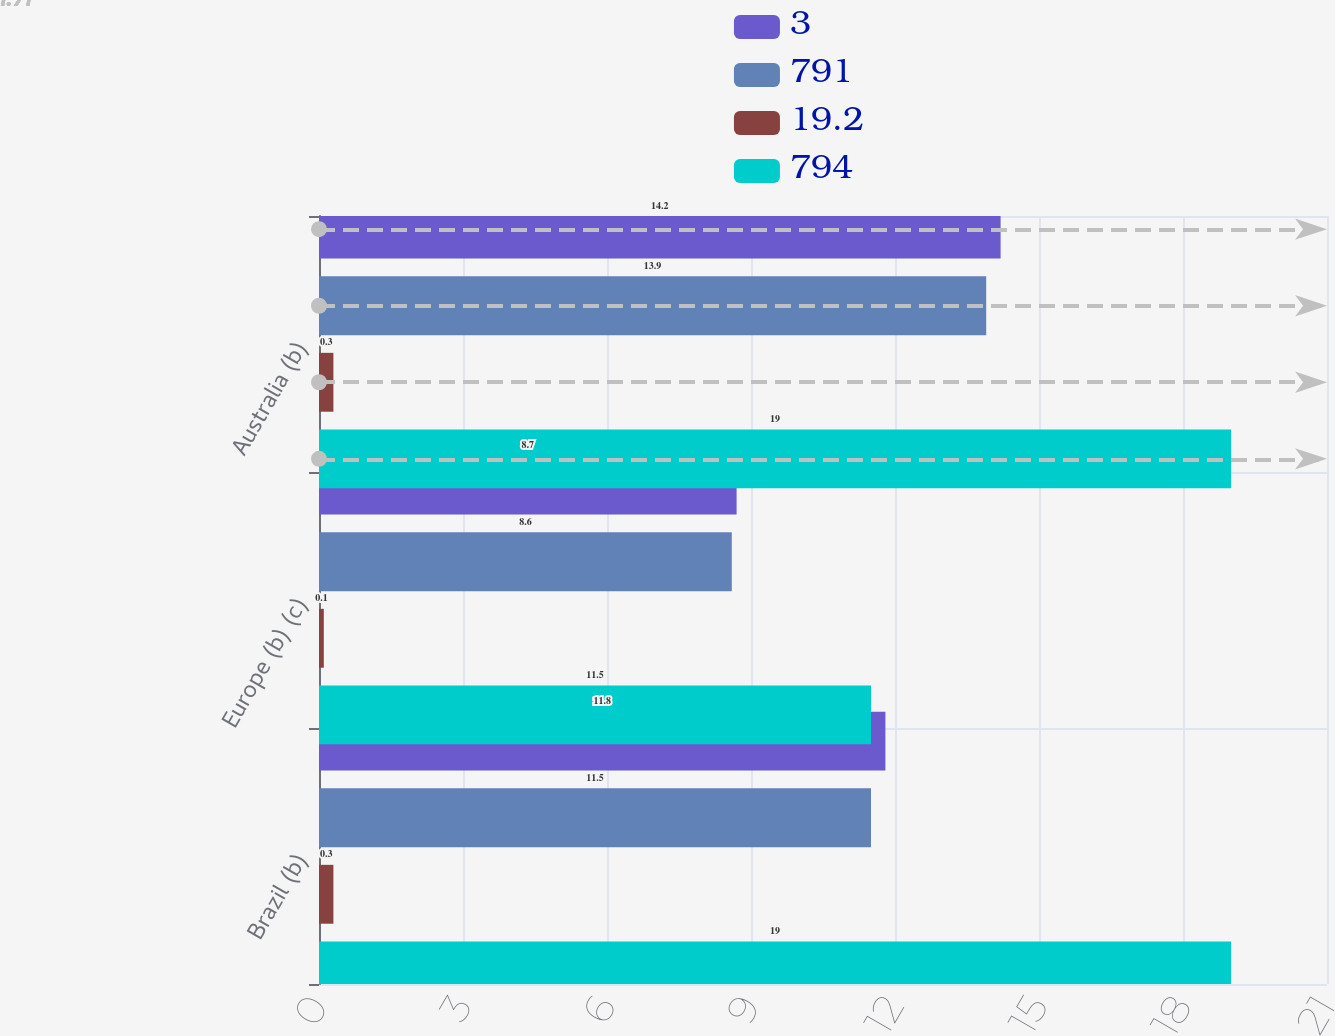Convert chart. <chart><loc_0><loc_0><loc_500><loc_500><stacked_bar_chart><ecel><fcel>Brazil (b)<fcel>Europe (b) (c)<fcel>Australia (b)<nl><fcel>3<fcel>11.8<fcel>8.7<fcel>14.2<nl><fcel>791<fcel>11.5<fcel>8.6<fcel>13.9<nl><fcel>19.2<fcel>0.3<fcel>0.1<fcel>0.3<nl><fcel>794<fcel>19<fcel>11.5<fcel>19<nl></chart> 